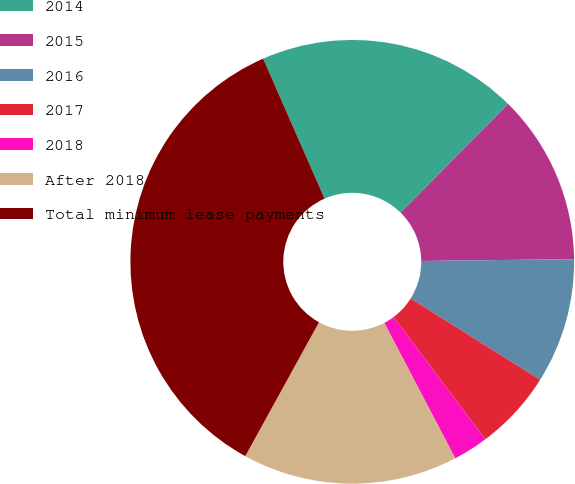Convert chart to OTSL. <chart><loc_0><loc_0><loc_500><loc_500><pie_chart><fcel>2014<fcel>2015<fcel>2016<fcel>2017<fcel>2018<fcel>After 2018<fcel>Total minimum lease payments<nl><fcel>18.98%<fcel>12.41%<fcel>9.12%<fcel>5.84%<fcel>2.55%<fcel>15.69%<fcel>35.41%<nl></chart> 